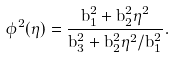<formula> <loc_0><loc_0><loc_500><loc_500>\phi ^ { 2 } ( \eta ) = \frac { b _ { 1 } ^ { 2 } + b _ { 2 } ^ { 2 } \eta ^ { 2 } } { b _ { 3 } ^ { 2 } + b _ { 2 } ^ { 2 } \eta ^ { 2 } / b _ { 1 } ^ { 2 } } .</formula> 